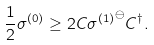Convert formula to latex. <formula><loc_0><loc_0><loc_500><loc_500>\frac { 1 } { 2 } \sigma ^ { ( 0 ) } \geq 2 C { \sigma ^ { ( 1 ) } } ^ { \ominus } C ^ { \dagger } .</formula> 